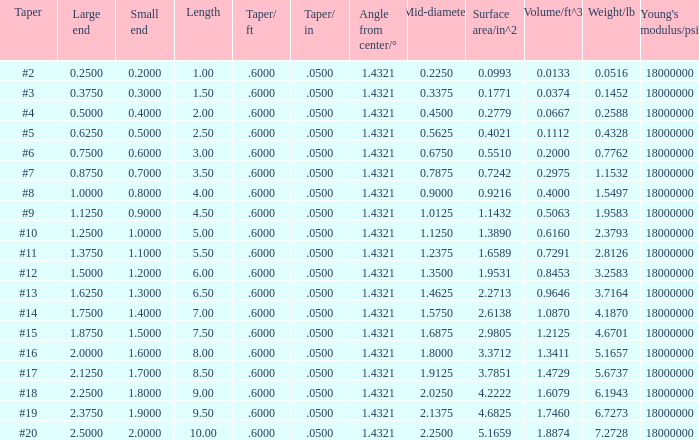Which Length has a Taper of #15, and a Large end larger than 1.875? None. 